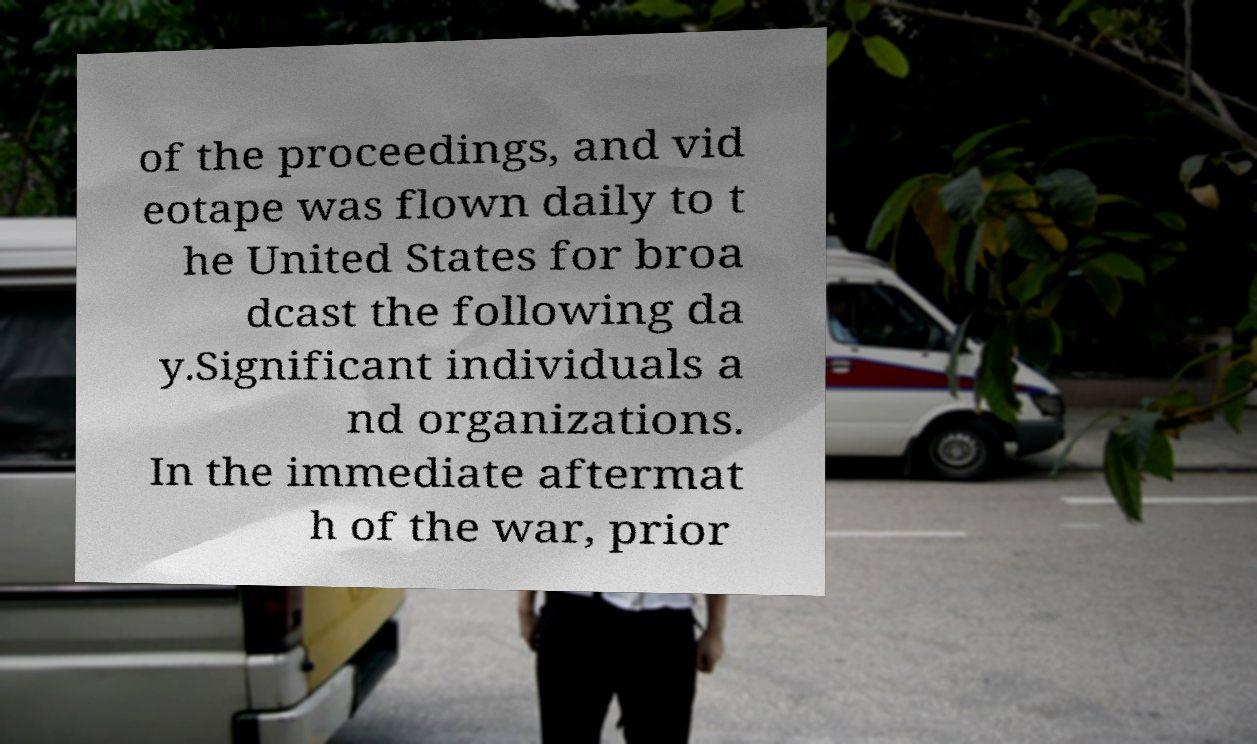Please read and relay the text visible in this image. What does it say? of the proceedings, and vid eotape was flown daily to t he United States for broa dcast the following da y.Significant individuals a nd organizations. In the immediate aftermat h of the war, prior 